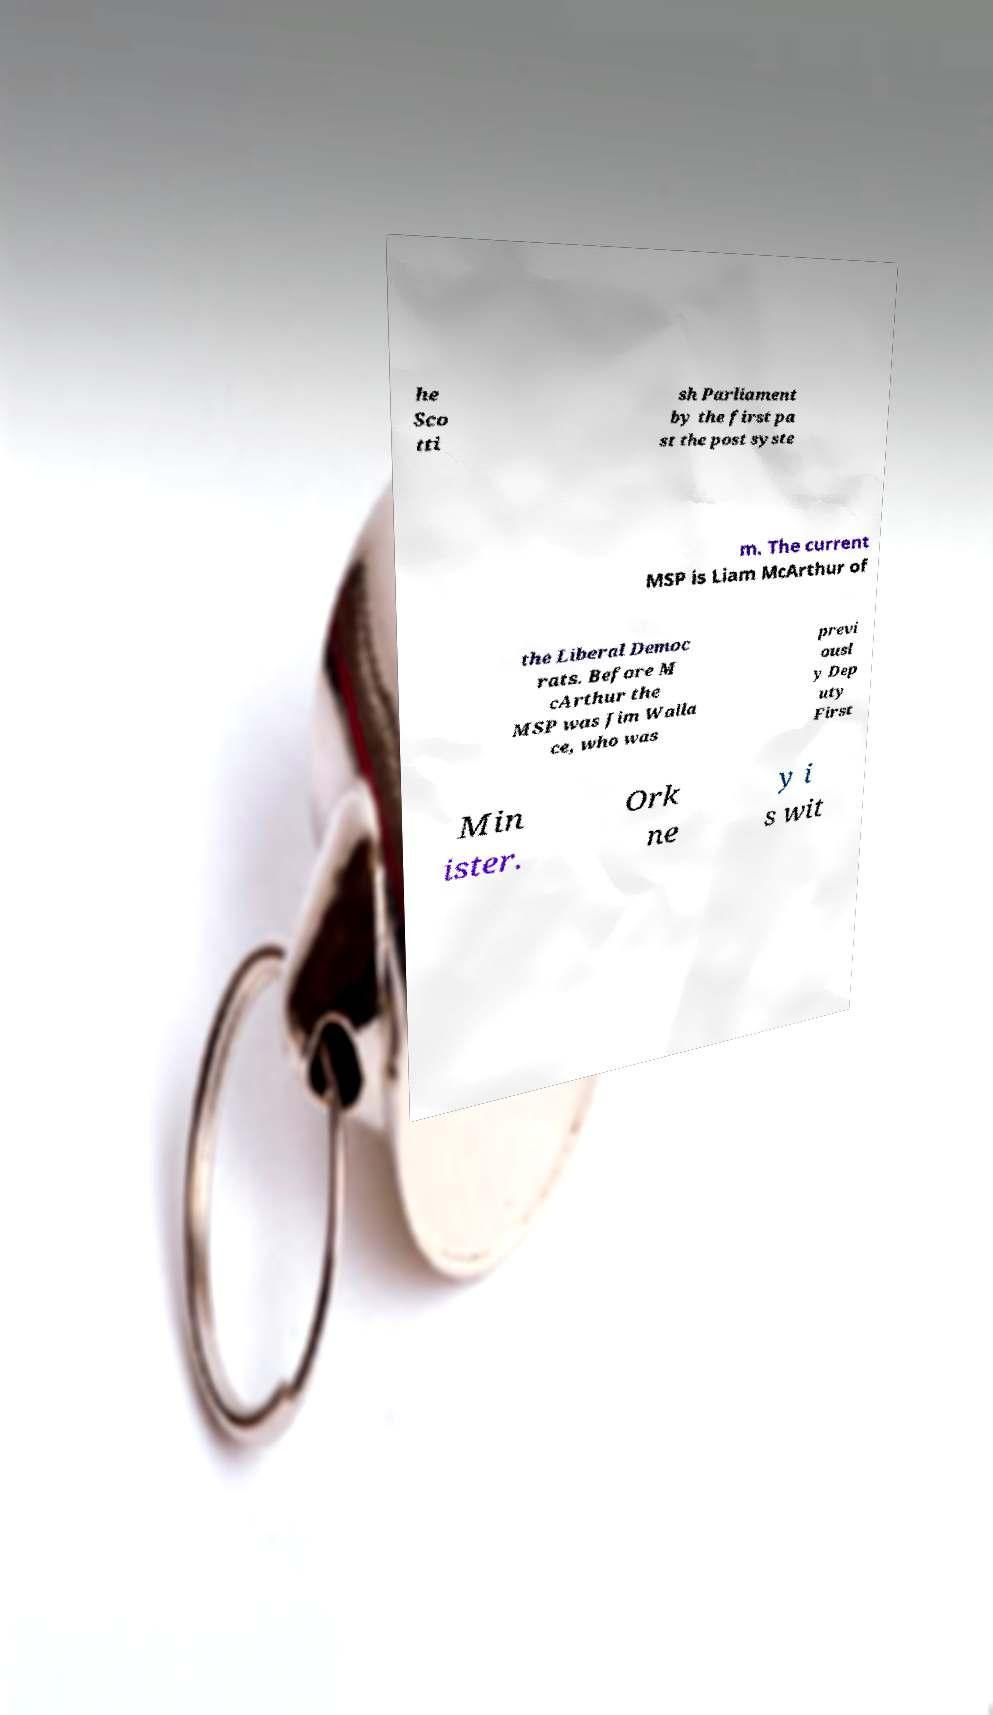What messages or text are displayed in this image? I need them in a readable, typed format. he Sco tti sh Parliament by the first pa st the post syste m. The current MSP is Liam McArthur of the Liberal Democ rats. Before M cArthur the MSP was Jim Walla ce, who was previ ousl y Dep uty First Min ister. Ork ne y i s wit 